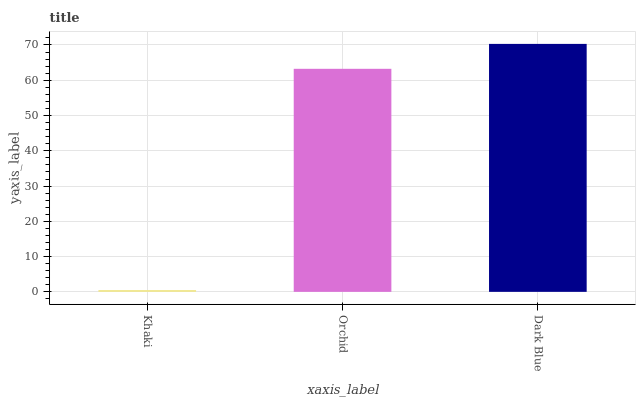Is Orchid the minimum?
Answer yes or no. No. Is Orchid the maximum?
Answer yes or no. No. Is Orchid greater than Khaki?
Answer yes or no. Yes. Is Khaki less than Orchid?
Answer yes or no. Yes. Is Khaki greater than Orchid?
Answer yes or no. No. Is Orchid less than Khaki?
Answer yes or no. No. Is Orchid the high median?
Answer yes or no. Yes. Is Orchid the low median?
Answer yes or no. Yes. Is Dark Blue the high median?
Answer yes or no. No. Is Khaki the low median?
Answer yes or no. No. 